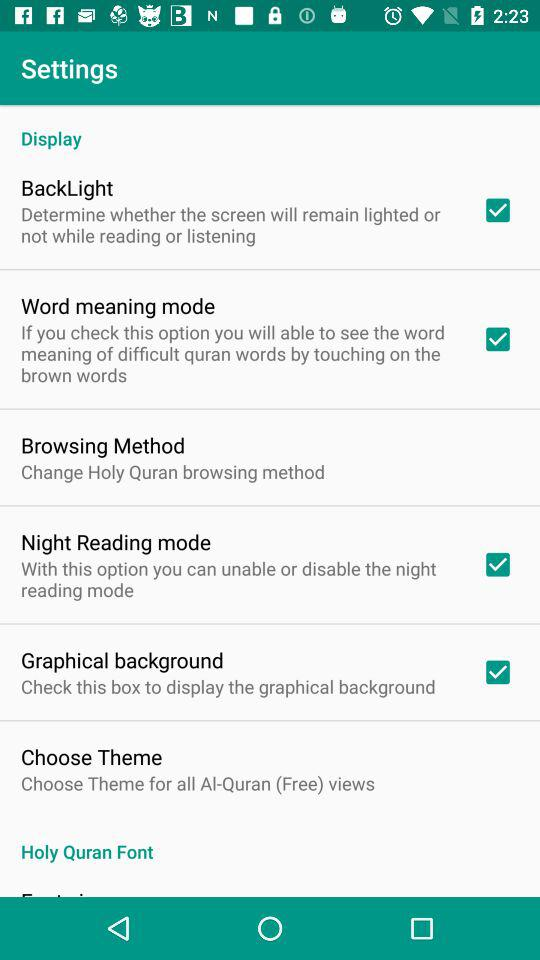How many checkboxes are in this settings screen? The settings screen displays a total of four checkboxes. Each checkbox is positioned next to an option, allowing users to easily toggle specific features on or off. The checked options are 'BackLight,' 'Word meaning mode,' 'Night Reading mode,' and 'Graphical background.' These options help customize the user's reading experience with the app. 